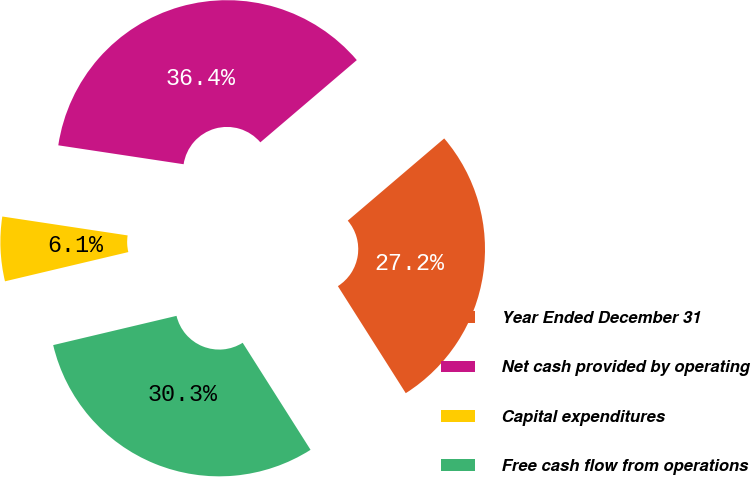Convert chart. <chart><loc_0><loc_0><loc_500><loc_500><pie_chart><fcel>Year Ended December 31<fcel>Net cash provided by operating<fcel>Capital expenditures<fcel>Free cash flow from operations<nl><fcel>27.24%<fcel>36.38%<fcel>6.09%<fcel>30.29%<nl></chart> 